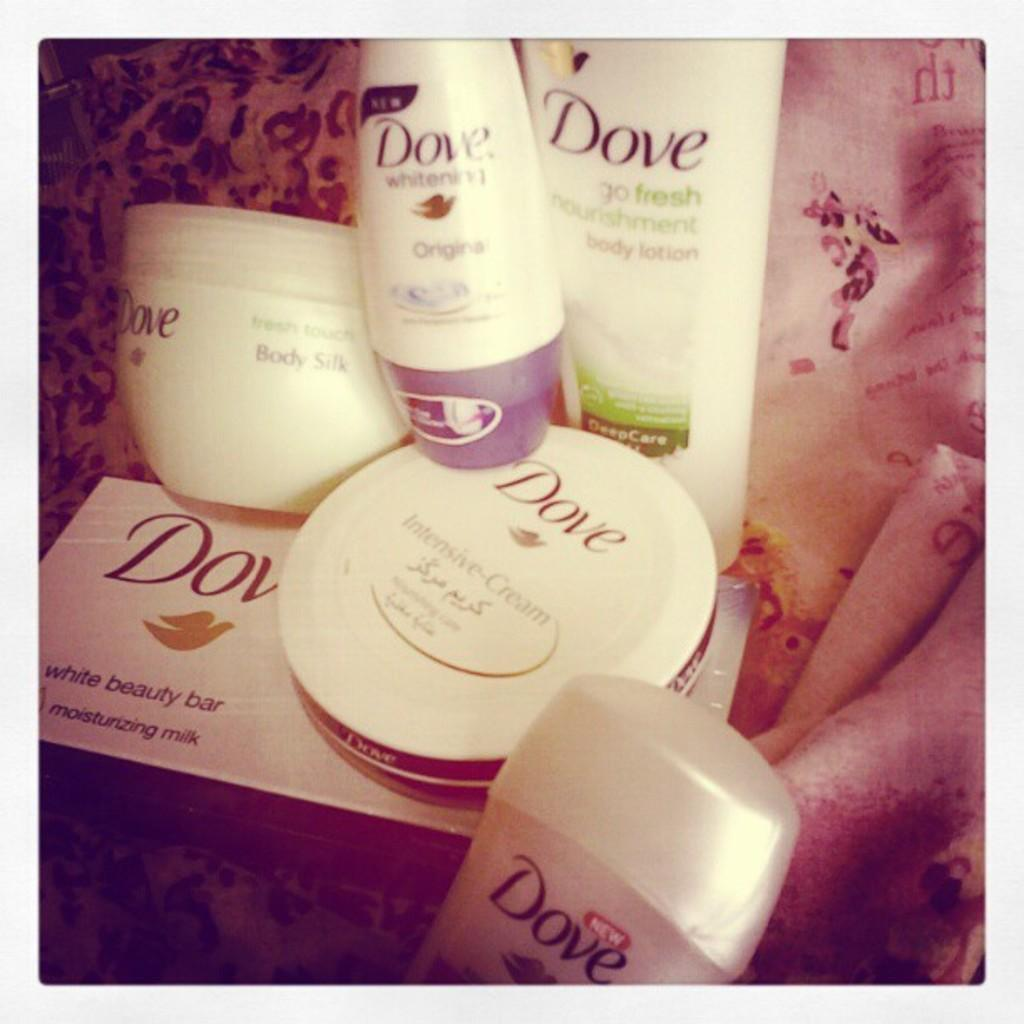<image>
Offer a succinct explanation of the picture presented. Bunch of Dove beauty products placed strategically together. 